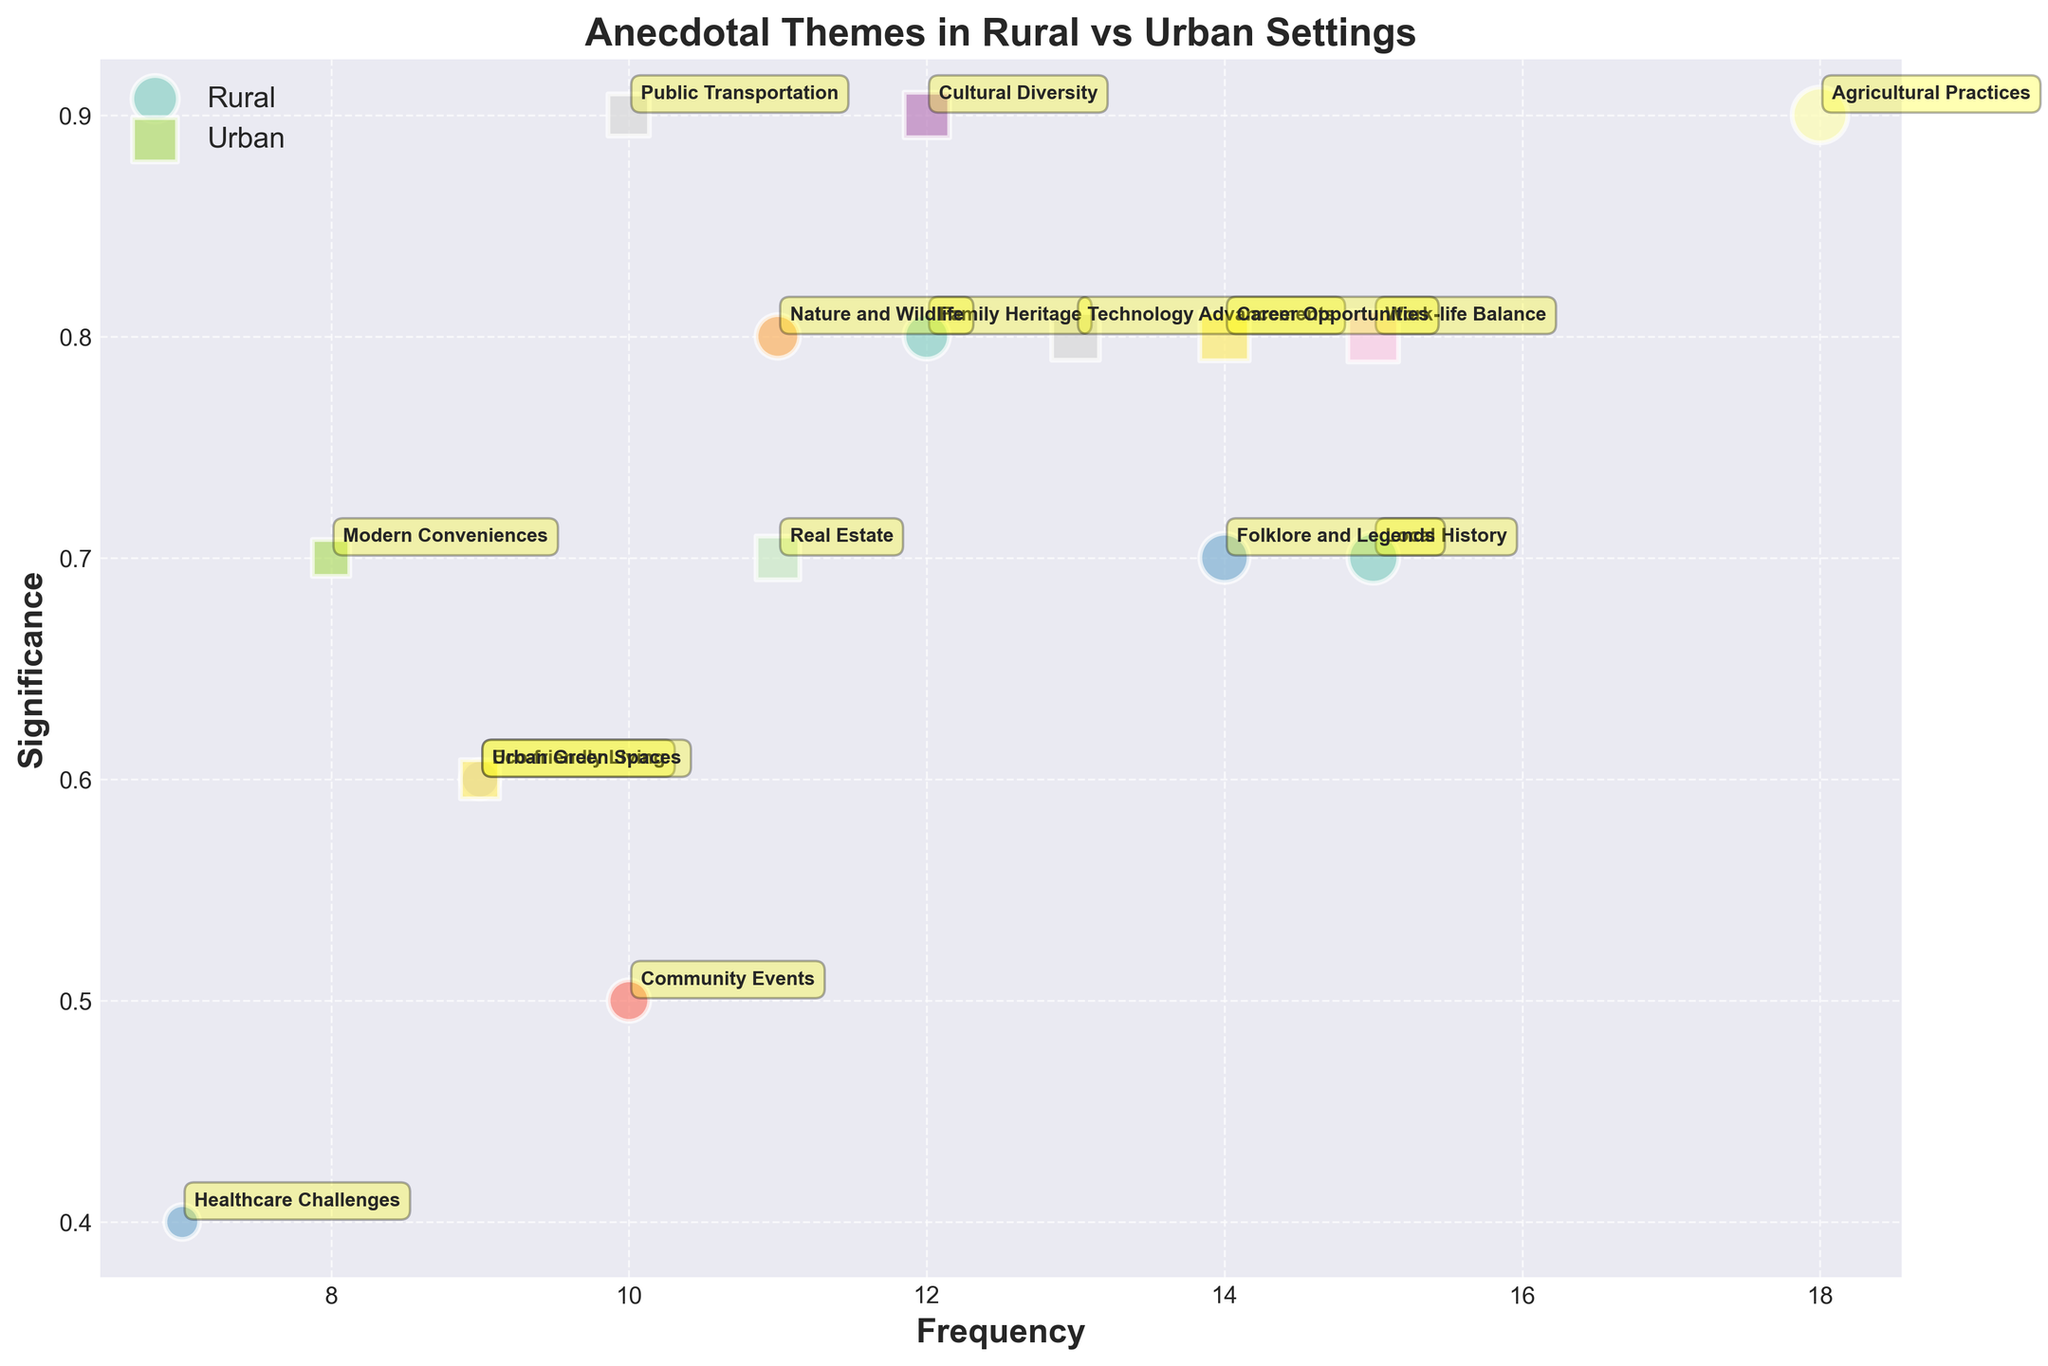what is the title of the plot? The title is usually displayed at the top of the plot. In this case, the title should be found directly above the chart content. It reads, "Anecdotal Themes in Rural vs Urban Settings."
Answer: Anecdotal Themes in Rural vs Urban Settings How many data points are there in total? Counting both rural and urban settings by adding them together: Rural has 8 and Urban has 8 data points, making a total of 16.
Answer: 16 Which anecdotal theme has the highest frequency in rural settings? By looking at the size of the bubbles in the rural section, we see that "Agricultural Practices" has the largest bubble, indicating the highest frequency with a value of 18.
Answer: Agricultural Practices What is the significance of the theme "Healthcare Challenges" in rural settings? Locate the bubble labeled "Healthcare Challenges" in the rural section and read off the Y-axis. The significance is 0.4.
Answer: 0.4 Which urban anecdotal theme has a frequency equal to that of the rural theme "Local History"? First, find the frequency of "Local History" in the rural setting, which is 15. Then locate an urban bubble with the same frequency, which is "Work-life Balance."
Answer: Work-life Balance Compare the significance of "Technology Advancements" and "Career Opportunities" in urban settings. Which has a higher significance and by how much? "Technology Advancements" has a significance of 0.8 and "Career Opportunities" has a significance of 0.8. The difference is 0, meaning they have equal significance.
Answer: They are equal What is the average frequency of the rural anecdotal themes? Sum of rural frequencies: 15+12+18+9+10+7+14+11=96. Number of rural themes: 8. Average: 96/8 = 12.
Answer: 12 Which setting discusses "Eco-friendly Living" and what is its significance? Locate the bubble labeled "Eco-friendly Living." It is in the rural section with a significance of 0.6.
Answer: Rural, 0.6 Does "Public Transportation" appear as a frequently discussed theme in rural settings? Check the rural section for the "Public Transportation" label. It is not present while it is in the urban section.
Answer: No In urban settings, which anecdotal theme has the smallest significance and what is its frequency? The smallest significance in urban settings could be found by identifying bubbles closest to the lowest Y-axis point. "Urban Green Spaces" has the smallest significance of 0.6 and a frequency of 9.
Answer: Urban Green Spaces, 9 